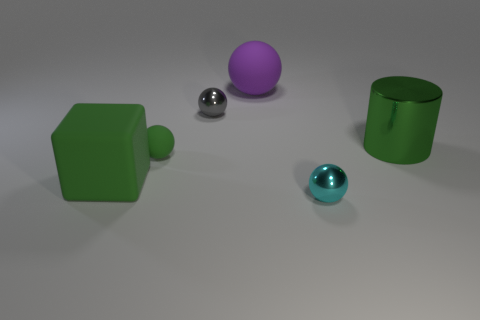There is a large object that is right of the big purple matte ball; what is its material?
Offer a terse response. Metal. Do the green matte block and the green shiny thing have the same size?
Provide a succinct answer. Yes. How many other objects are the same size as the cylinder?
Provide a succinct answer. 2. Is the color of the big rubber block the same as the shiny cylinder?
Give a very brief answer. Yes. The large green object on the left side of the small object that is left of the tiny thing behind the green metal object is what shape?
Your answer should be very brief. Cube. What number of objects are matte things to the right of the tiny green rubber sphere or tiny balls left of the tiny cyan thing?
Keep it short and to the point. 3. What is the size of the green object that is in front of the matte ball in front of the large rubber ball?
Your answer should be compact. Large. Do the large matte object to the right of the big green rubber thing and the big shiny thing have the same color?
Ensure brevity in your answer.  No. Are there any other large green things that have the same shape as the big green metal object?
Keep it short and to the point. No. The other metal object that is the same size as the cyan object is what color?
Your answer should be compact. Gray. 